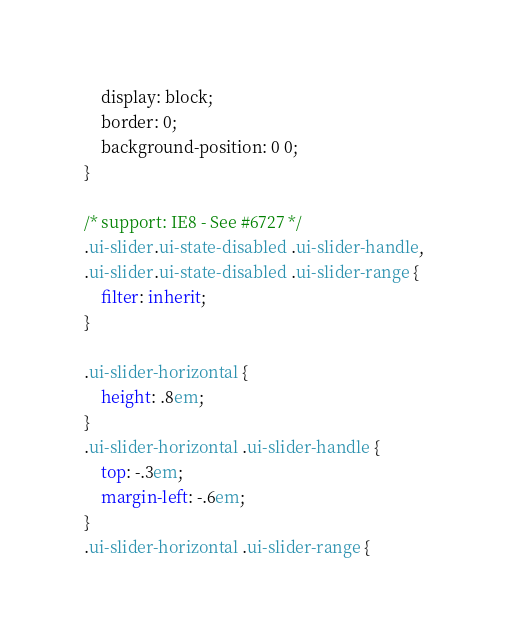<code> <loc_0><loc_0><loc_500><loc_500><_CSS_>    display: block;
    border: 0;
    background-position: 0 0;
}

/* support: IE8 - See #6727 */
.ui-slider.ui-state-disabled .ui-slider-handle,
.ui-slider.ui-state-disabled .ui-slider-range {
    filter: inherit;
}

.ui-slider-horizontal {
    height: .8em;
}
.ui-slider-horizontal .ui-slider-handle {
    top: -.3em;
    margin-left: -.6em;
}
.ui-slider-horizontal .ui-slider-range {</code> 